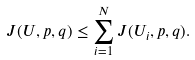<formula> <loc_0><loc_0><loc_500><loc_500>J ( U , p , q ) \leq \sum _ { i = 1 } ^ { N } J ( U _ { i } , p , q ) .</formula> 